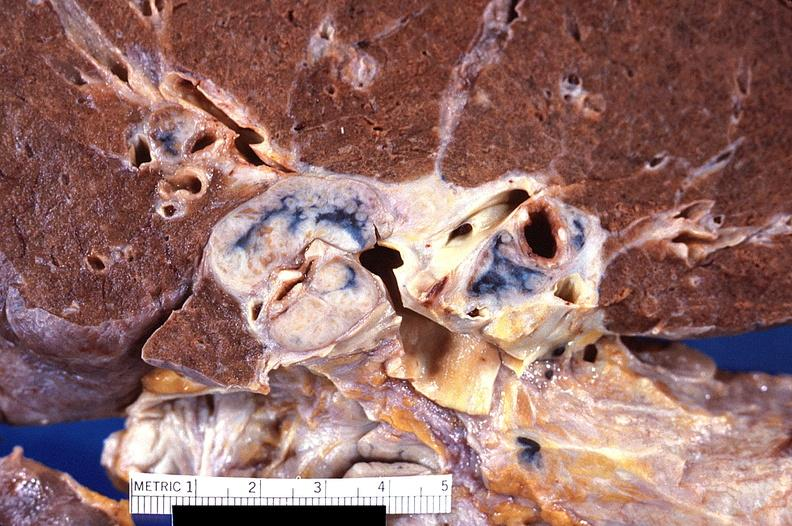what does this image show?
Answer the question using a single word or phrase. Hilar lymph nodes 